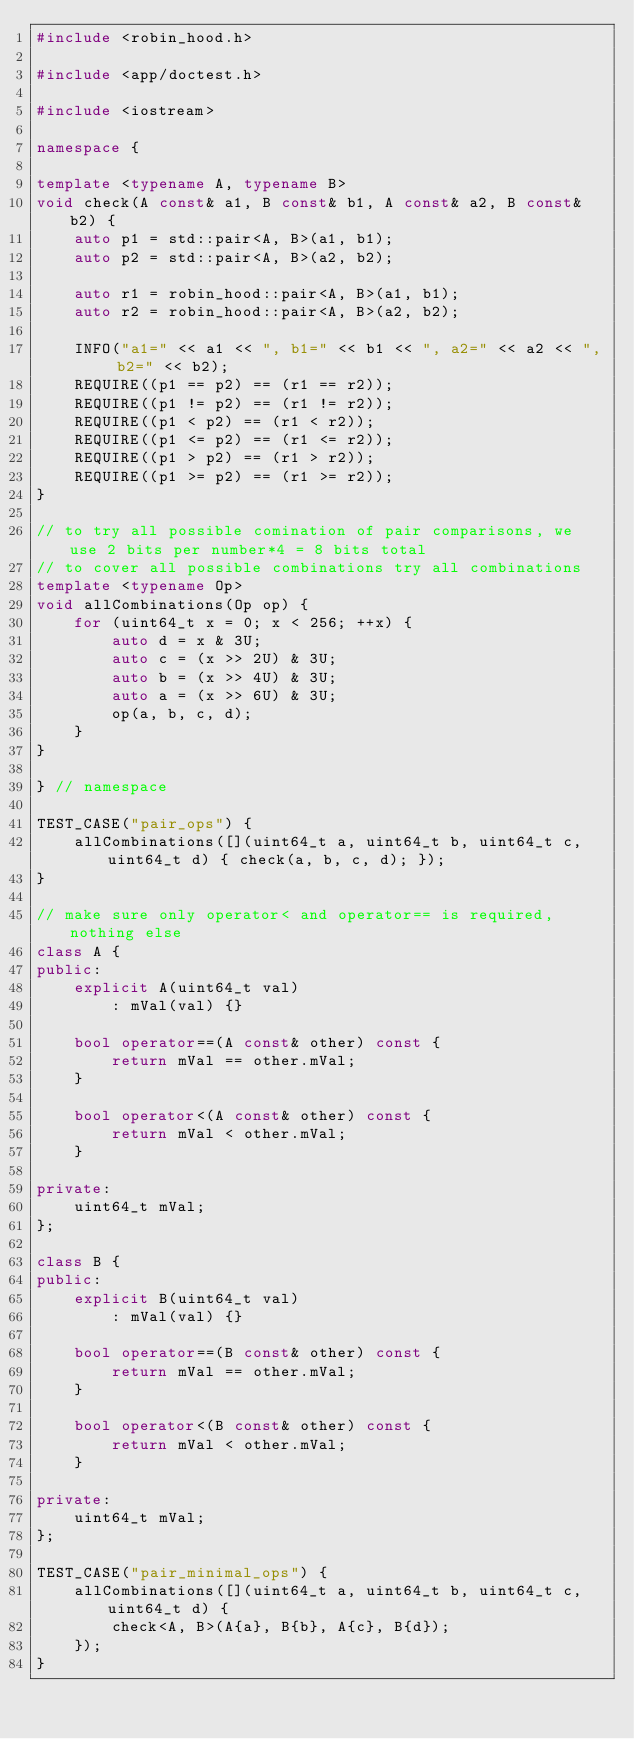Convert code to text. <code><loc_0><loc_0><loc_500><loc_500><_C++_>#include <robin_hood.h>

#include <app/doctest.h>

#include <iostream>

namespace {

template <typename A, typename B>
void check(A const& a1, B const& b1, A const& a2, B const& b2) {
    auto p1 = std::pair<A, B>(a1, b1);
    auto p2 = std::pair<A, B>(a2, b2);

    auto r1 = robin_hood::pair<A, B>(a1, b1);
    auto r2 = robin_hood::pair<A, B>(a2, b2);

    INFO("a1=" << a1 << ", b1=" << b1 << ", a2=" << a2 << ", b2=" << b2);
    REQUIRE((p1 == p2) == (r1 == r2));
    REQUIRE((p1 != p2) == (r1 != r2));
    REQUIRE((p1 < p2) == (r1 < r2));
    REQUIRE((p1 <= p2) == (r1 <= r2));
    REQUIRE((p1 > p2) == (r1 > r2));
    REQUIRE((p1 >= p2) == (r1 >= r2));
}

// to try all possible comination of pair comparisons, we use 2 bits per number*4 = 8 bits total
// to cover all possible combinations try all combinations
template <typename Op>
void allCombinations(Op op) {
    for (uint64_t x = 0; x < 256; ++x) {
        auto d = x & 3U;
        auto c = (x >> 2U) & 3U;
        auto b = (x >> 4U) & 3U;
        auto a = (x >> 6U) & 3U;
        op(a, b, c, d);
    }
}

} // namespace

TEST_CASE("pair_ops") {
    allCombinations([](uint64_t a, uint64_t b, uint64_t c, uint64_t d) { check(a, b, c, d); });
}

// make sure only operator< and operator== is required, nothing else
class A {
public:
    explicit A(uint64_t val)
        : mVal(val) {}

    bool operator==(A const& other) const {
        return mVal == other.mVal;
    }

    bool operator<(A const& other) const {
        return mVal < other.mVal;
    }

private:
    uint64_t mVal;
};

class B {
public:
    explicit B(uint64_t val)
        : mVal(val) {}

    bool operator==(B const& other) const {
        return mVal == other.mVal;
    }

    bool operator<(B const& other) const {
        return mVal < other.mVal;
    }

private:
    uint64_t mVal;
};

TEST_CASE("pair_minimal_ops") {
    allCombinations([](uint64_t a, uint64_t b, uint64_t c, uint64_t d) {
        check<A, B>(A{a}, B{b}, A{c}, B{d});
    });
}
</code> 